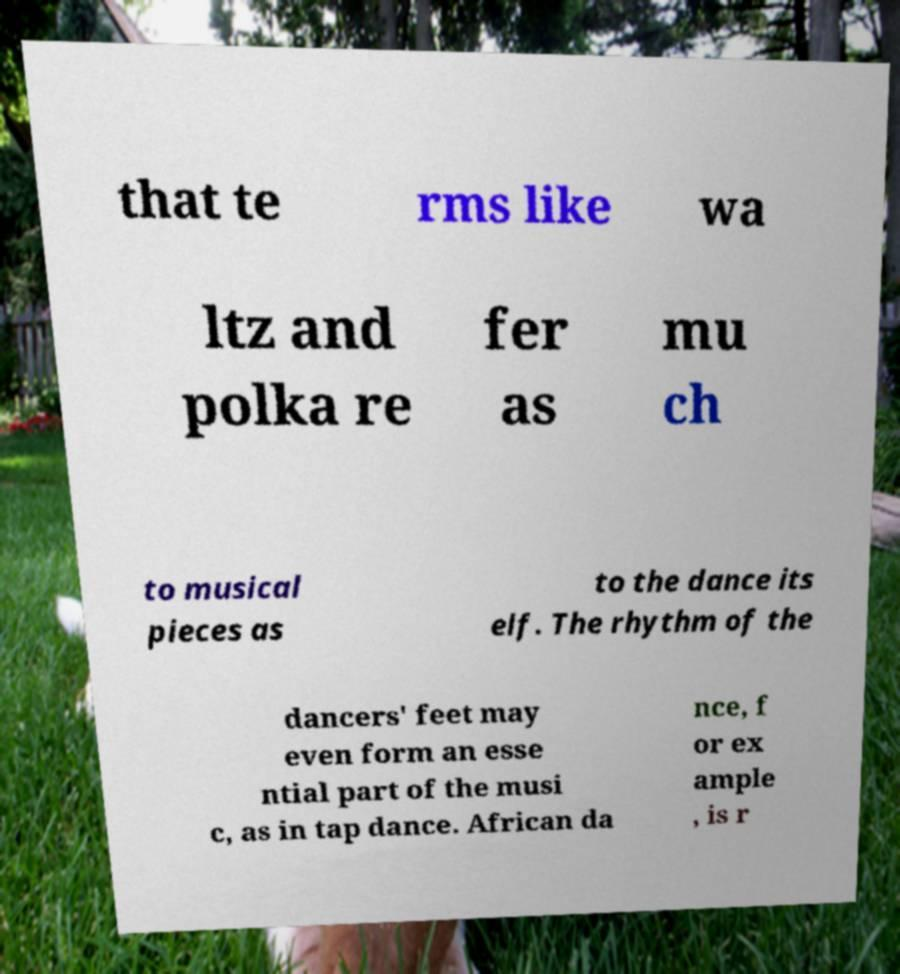Can you read and provide the text displayed in the image?This photo seems to have some interesting text. Can you extract and type it out for me? that te rms like wa ltz and polka re fer as mu ch to musical pieces as to the dance its elf. The rhythm of the dancers' feet may even form an esse ntial part of the musi c, as in tap dance. African da nce, f or ex ample , is r 